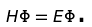Convert formula to latex. <formula><loc_0><loc_0><loc_500><loc_500>H \Phi = E \Phi \text {.}</formula> 